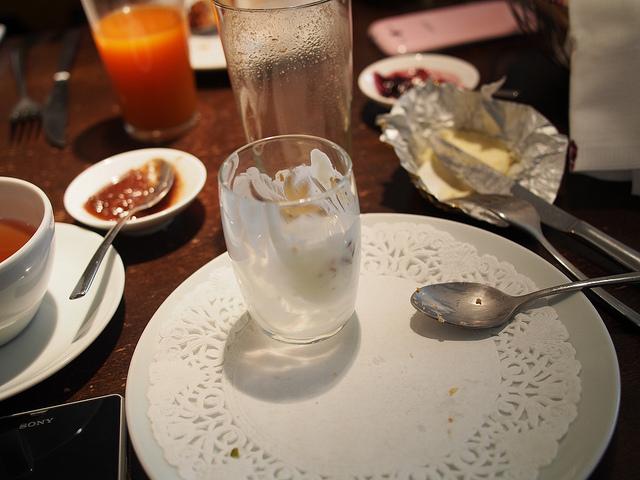Is the cup in front empty?
Concise answer only. No. What is laying in front of the glasses?
Concise answer only. Spoon. How many ice cream bowls?
Keep it brief. 0. What is being poured in a cup?
Give a very brief answer. Water. What is the shadow of?
Answer briefly. Glass. What is the clear liquid in the glass?
Write a very short answer. Water. What beverage is on the placemat?
Be succinct. Water. What surface are the glasses sitting on?
Keep it brief. Table. What is in the glass?
Short answer required. Ice cream. How many glasses are in this picture?
Be succinct. 3. They are sitting on a white saucer. It looks like Italian coffee?
Quick response, please. No. What is in the cup to the left?
Keep it brief. Soup. What is this person drinking?
Concise answer only. Water. Is this a home cooked or restaurant meal?
Concise answer only. Restaurant. What is your favorite brand of orange juice?
Answer briefly. Tropicana. What is in the glasses?
Concise answer only. Ice cream. What liquid is in the glass?
Give a very brief answer. Water. Are any of the glasses empty?
Quick response, please. Yes. How many spoons are on the table?
Keep it brief. 2. How many cell phones are on the table?
Quick response, please. 2. How many utensils?
Quick response, please. 4. How many wine glasses are there?
Answer briefly. 0. 